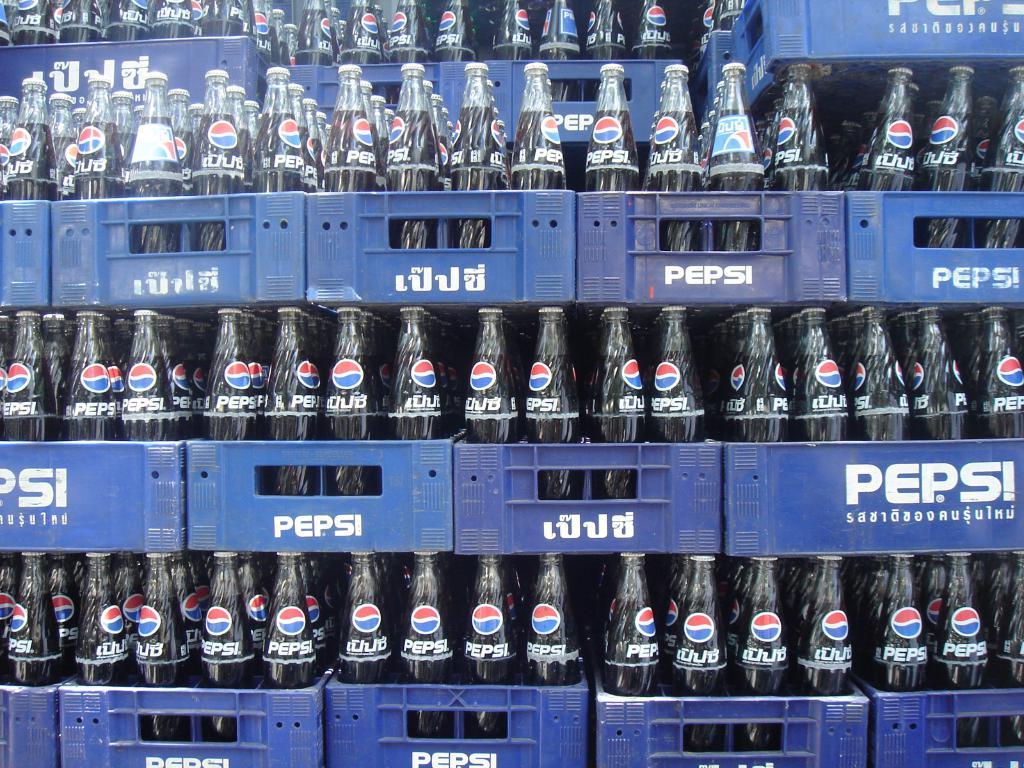What is your favorite drink?
Make the answer very short. Answering does not require reading text in the image. What brand of soda is in the bottles?
Give a very brief answer. Pepsi. 